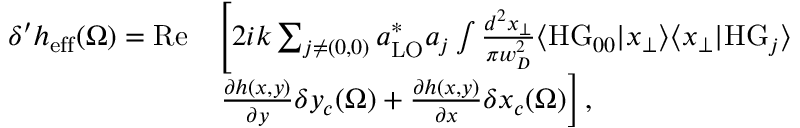<formula> <loc_0><loc_0><loc_500><loc_500>\begin{array} { r l } { \delta ^ { \prime } h _ { e f f } ( \Omega ) = R e } & { \left [ 2 i k \sum _ { j \neq ( 0 , 0 ) } a _ { L O } ^ { * } a _ { j } \int \frac { d ^ { 2 } x _ { \perp } } { \pi w _ { D } ^ { 2 } } \langle H G _ { 0 0 } | x _ { \perp } \rangle \langle x _ { \perp } | H G _ { j } \rangle } \\ & { \frac { \partial h ( x , y ) } { \partial y } \delta y _ { c } ( \Omega ) + \frac { \partial h ( x , y ) } { \partial x } \delta x _ { c } ( \Omega ) \right ] , } \end{array}</formula> 